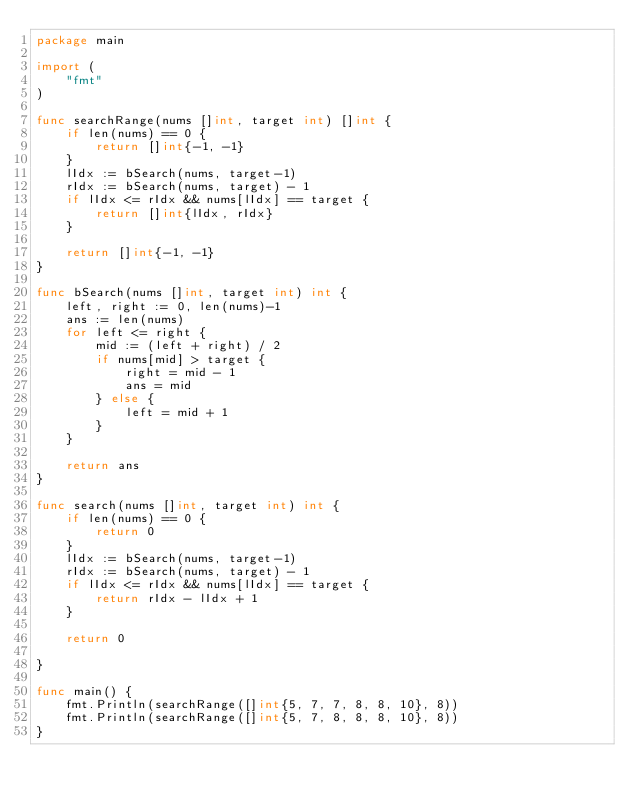Convert code to text. <code><loc_0><loc_0><loc_500><loc_500><_Go_>package main

import (
	"fmt"
)

func searchRange(nums []int, target int) []int {
	if len(nums) == 0 {
		return []int{-1, -1}
	}
	lIdx := bSearch(nums, target-1)
	rIdx := bSearch(nums, target) - 1
	if lIdx <= rIdx && nums[lIdx] == target {
		return []int{lIdx, rIdx}
	}

	return []int{-1, -1}
}

func bSearch(nums []int, target int) int {
	left, right := 0, len(nums)-1
	ans := len(nums)
	for left <= right {
		mid := (left + right) / 2
		if nums[mid] > target {
			right = mid - 1
			ans = mid
		} else {
			left = mid + 1
		}
	}

	return ans
}

func search(nums []int, target int) int {
	if len(nums) == 0 {
		return 0
	}
	lIdx := bSearch(nums, target-1)
	rIdx := bSearch(nums, target) - 1
	if lIdx <= rIdx && nums[lIdx] == target {
		return rIdx - lIdx + 1
	}

	return 0

}

func main() {
	fmt.Println(searchRange([]int{5, 7, 7, 8, 8, 10}, 8))
	fmt.Println(searchRange([]int{5, 7, 8, 8, 8, 10}, 8))
}
</code> 